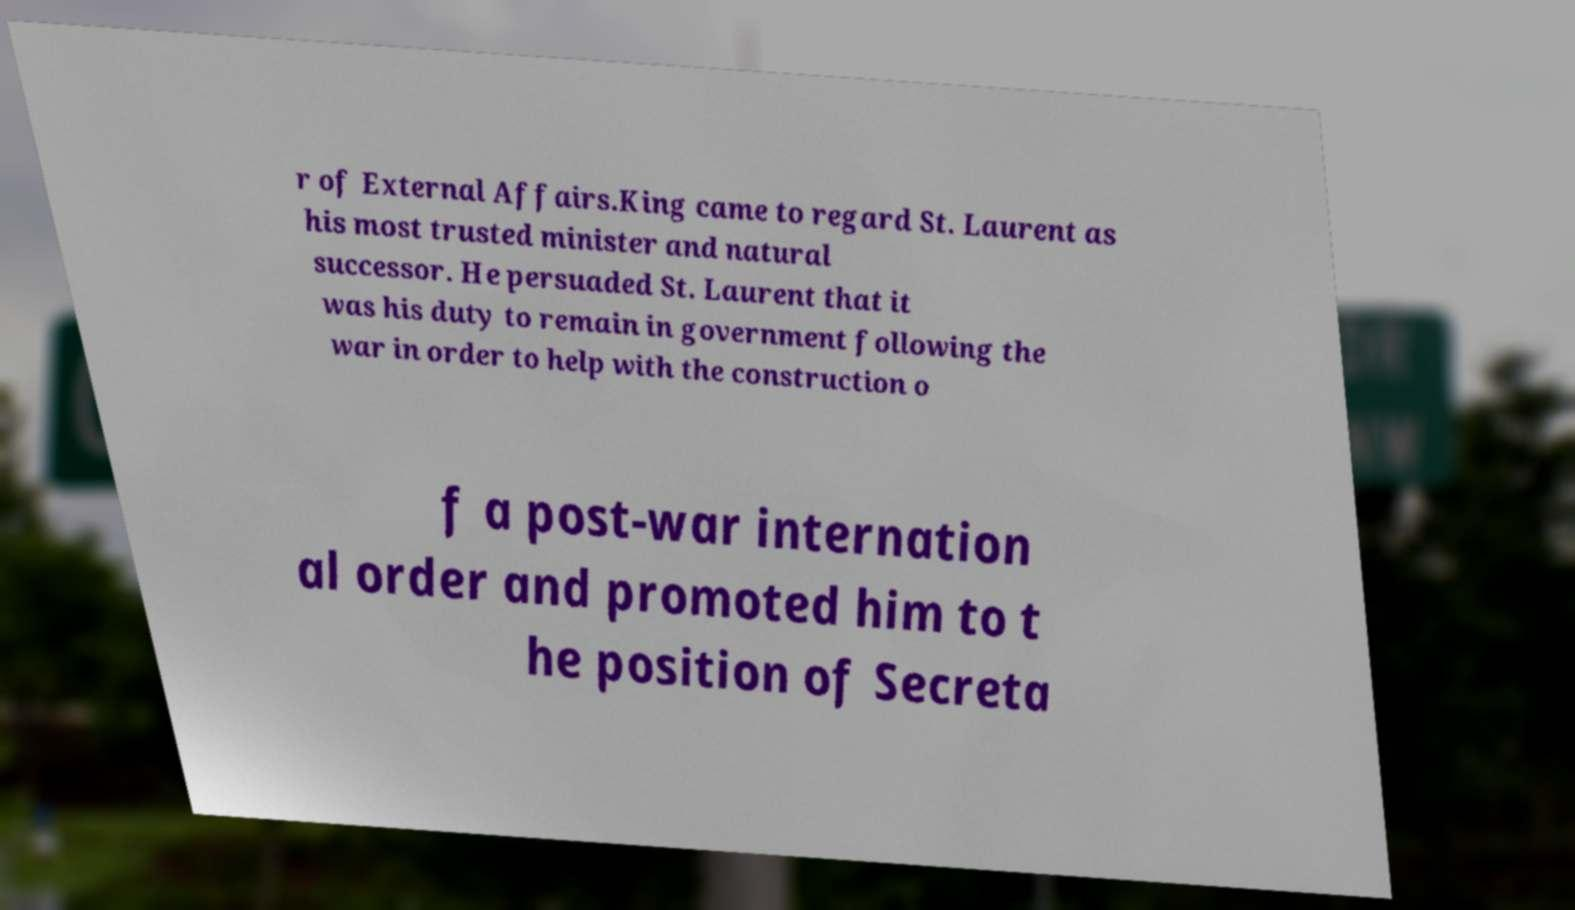Can you read and provide the text displayed in the image?This photo seems to have some interesting text. Can you extract and type it out for me? r of External Affairs.King came to regard St. Laurent as his most trusted minister and natural successor. He persuaded St. Laurent that it was his duty to remain in government following the war in order to help with the construction o f a post-war internation al order and promoted him to t he position of Secreta 